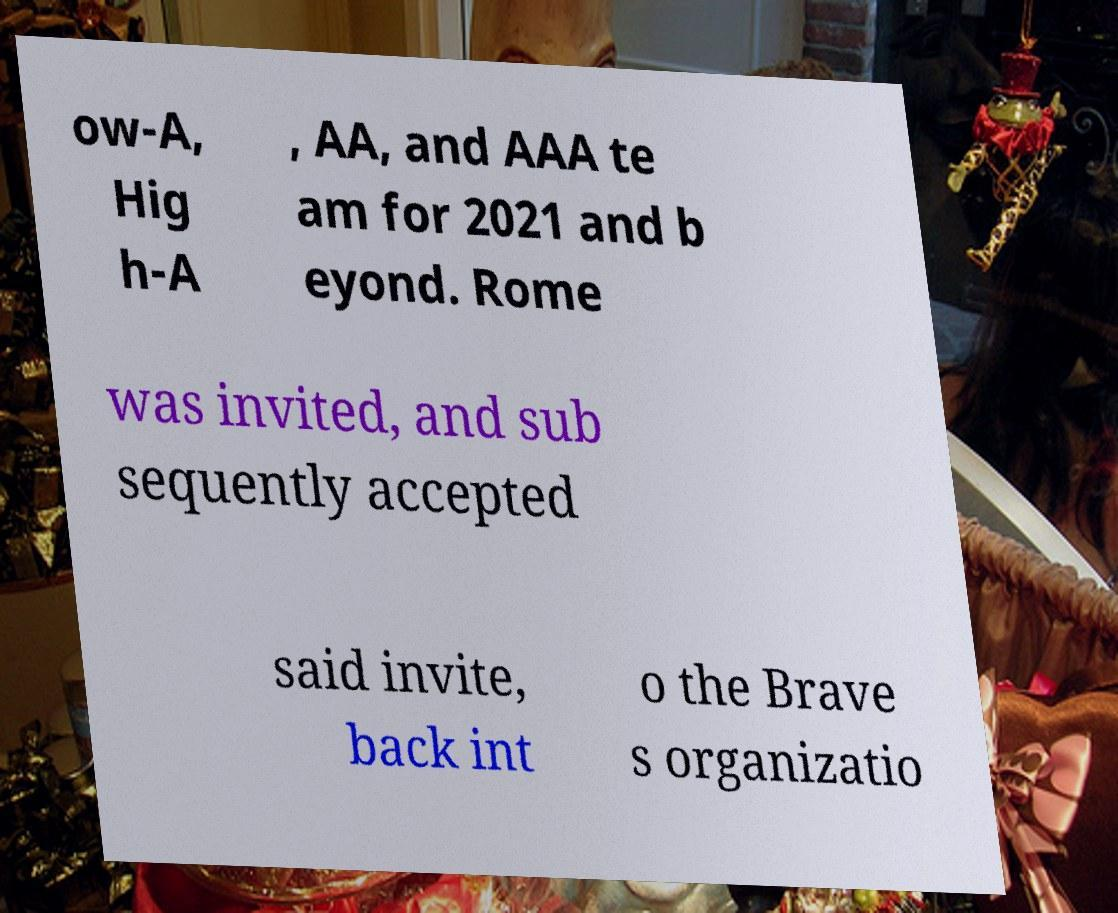There's text embedded in this image that I need extracted. Can you transcribe it verbatim? ow-A, Hig h-A , AA, and AAA te am for 2021 and b eyond. Rome was invited, and sub sequently accepted said invite, back int o the Brave s organizatio 